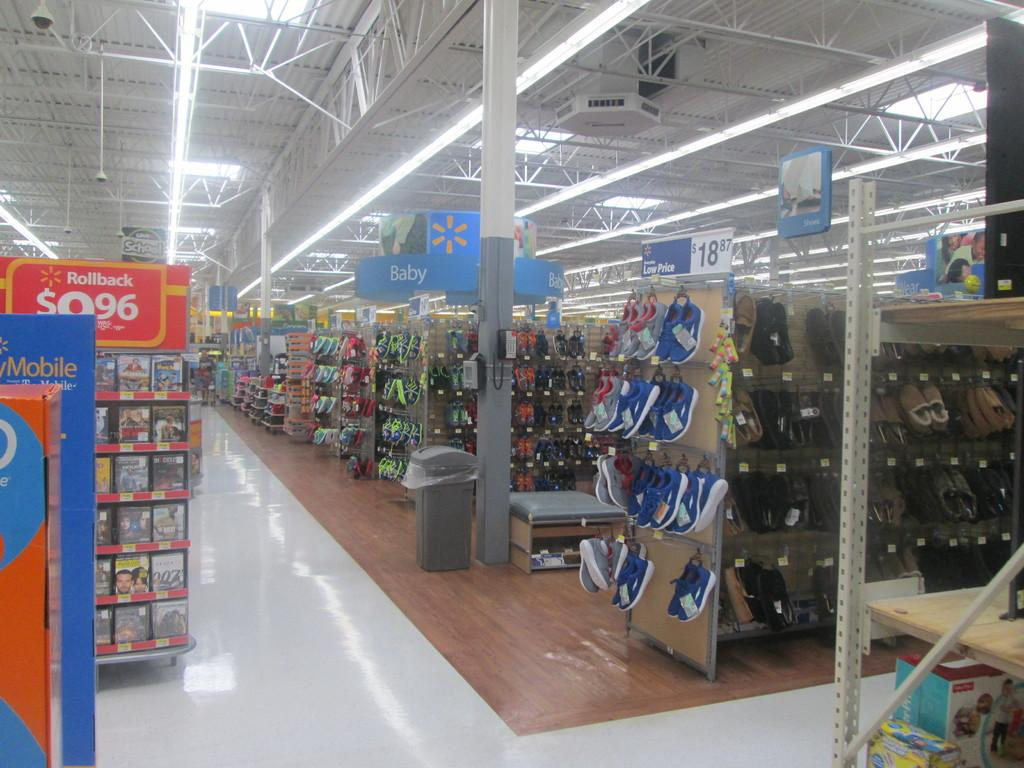<image>
Share a concise interpretation of the image provided. An aisle inside of a Wal-Mart store near the Baby section. 